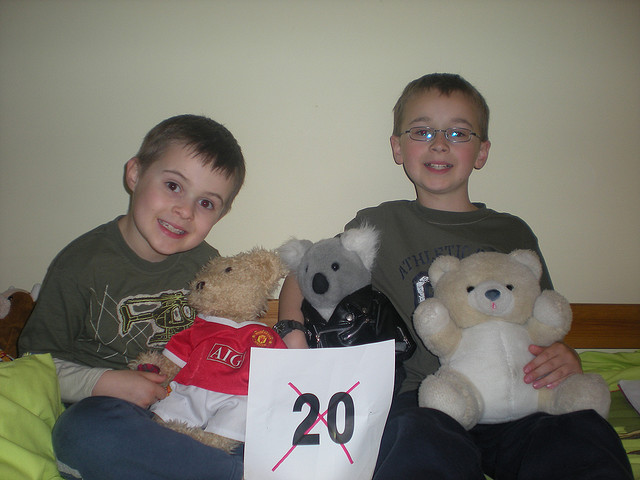How many bears are being held? There are three bears in the image, each with distinctive features and attire. One bear is dressed in a red shirt with 'AIG' written on it, another is a koala bear, and the third is a traditional teddy bear in a simple, light color. 